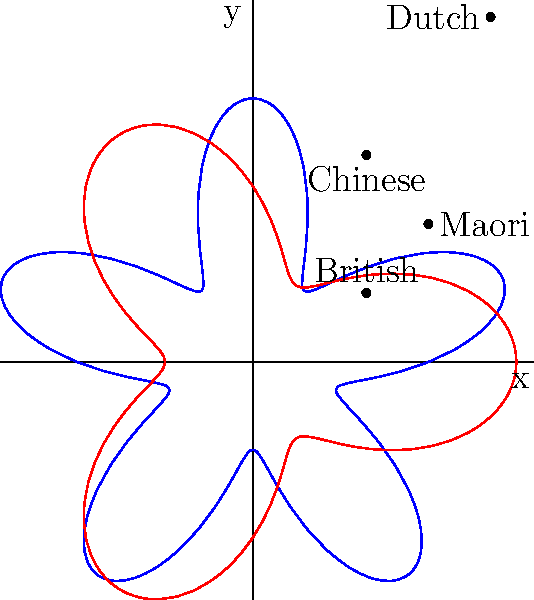In the polar rose plot representing immigrant groups in early New Zealand cities, which group appears to have the most evenly distributed presence across different regions, as indicated by the shape of its curve? To answer this question, we need to analyze the shapes of the curves in the polar rose plot:

1. The blue curve represents one immigrant group, while the red curve represents another.

2. A more evenly distributed presence across regions would be represented by a curve that has a more consistent distance from the origin in all directions.

3. The blue curve (representing British immigrants) has five distinct "petals" with sharp peaks and valleys, indicating a less even distribution across regions.

4. The red curve (representing Maori population) has three wider, more rounded "petals" with less pronounced peaks and valleys.

5. The more rounded and consistent shape of the red curve suggests a more even distribution across different regions compared to the blue curve.

6. Based on historical context, the Maori, as the indigenous people of New Zealand, would likely have had a more widespread and even presence across different regions in early colonial cities compared to immigrant groups.

Therefore, the red curve, which represents the Maori population, appears to show the most evenly distributed presence across different regions in early New Zealand cities.
Answer: Maori 